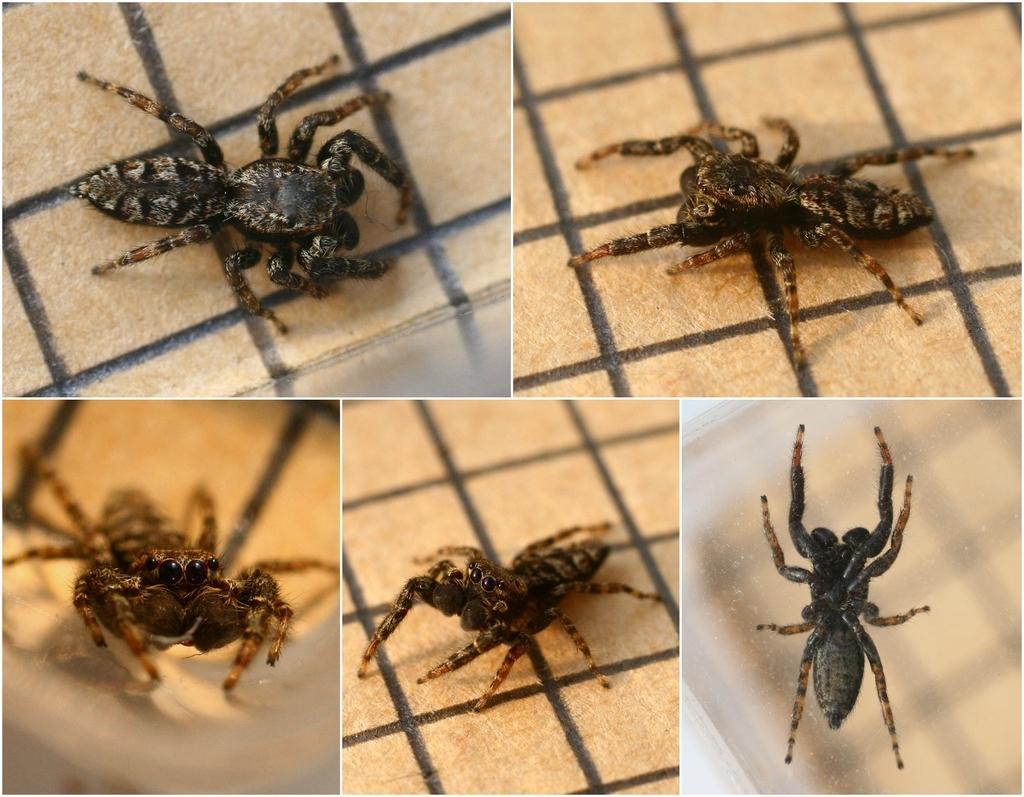Can you describe this image briefly? This is a collage picture, in this picture we can see spiders on the ground. 